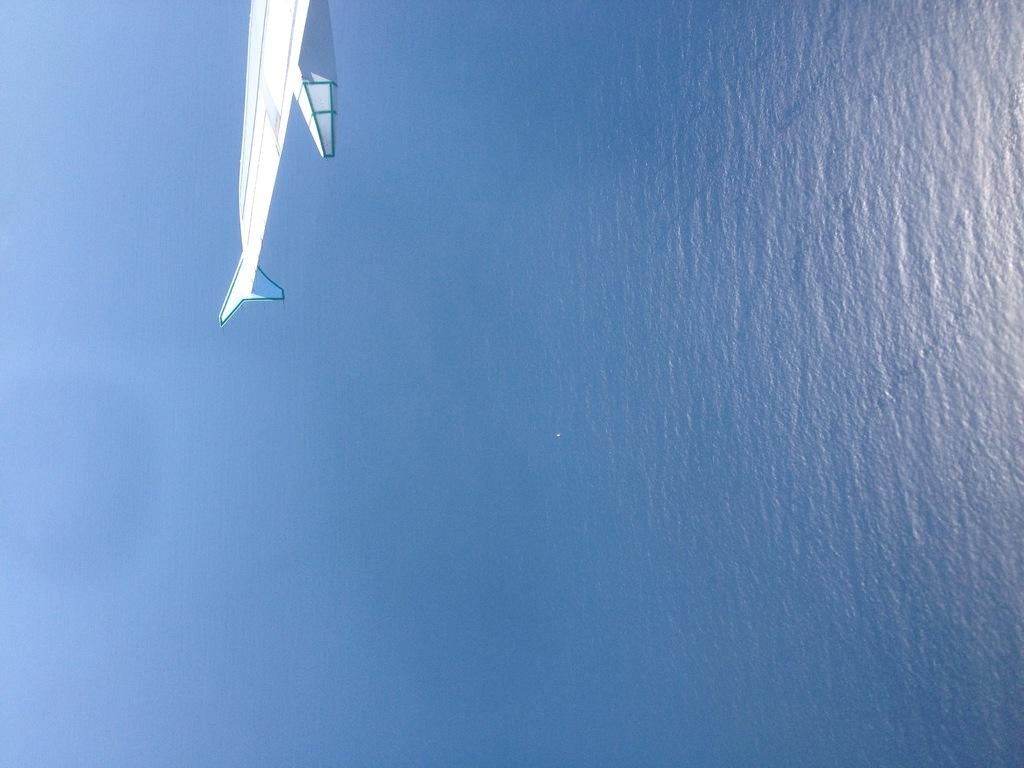What is the primary element visible in the image? There is water present in the image. What else can be seen in the image besides water? There is a wing of an aircraft in the image. How is the wing of the aircraft positioned in the image? The wing of the aircraft is in the air. What type of test can be seen floating on the water in the image? There is no test present in the image; it only features water and the wing of an aircraft. How many stars are visible in the image? There are no stars visible in the image, as it primarily features water and the wing of an aircraft. 